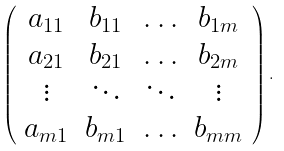Convert formula to latex. <formula><loc_0><loc_0><loc_500><loc_500>\left ( \begin{array} { c c c c } a _ { 1 1 } & b _ { 1 1 } & \hdots & b _ { 1 m } \\ a _ { 2 1 } & b _ { 2 1 } & \hdots & b _ { 2 m } \\ \vdots & \ddots & \ddots & \vdots \\ a _ { m 1 } & b _ { m 1 } & \hdots & b _ { m m } \end{array} \right ) .</formula> 